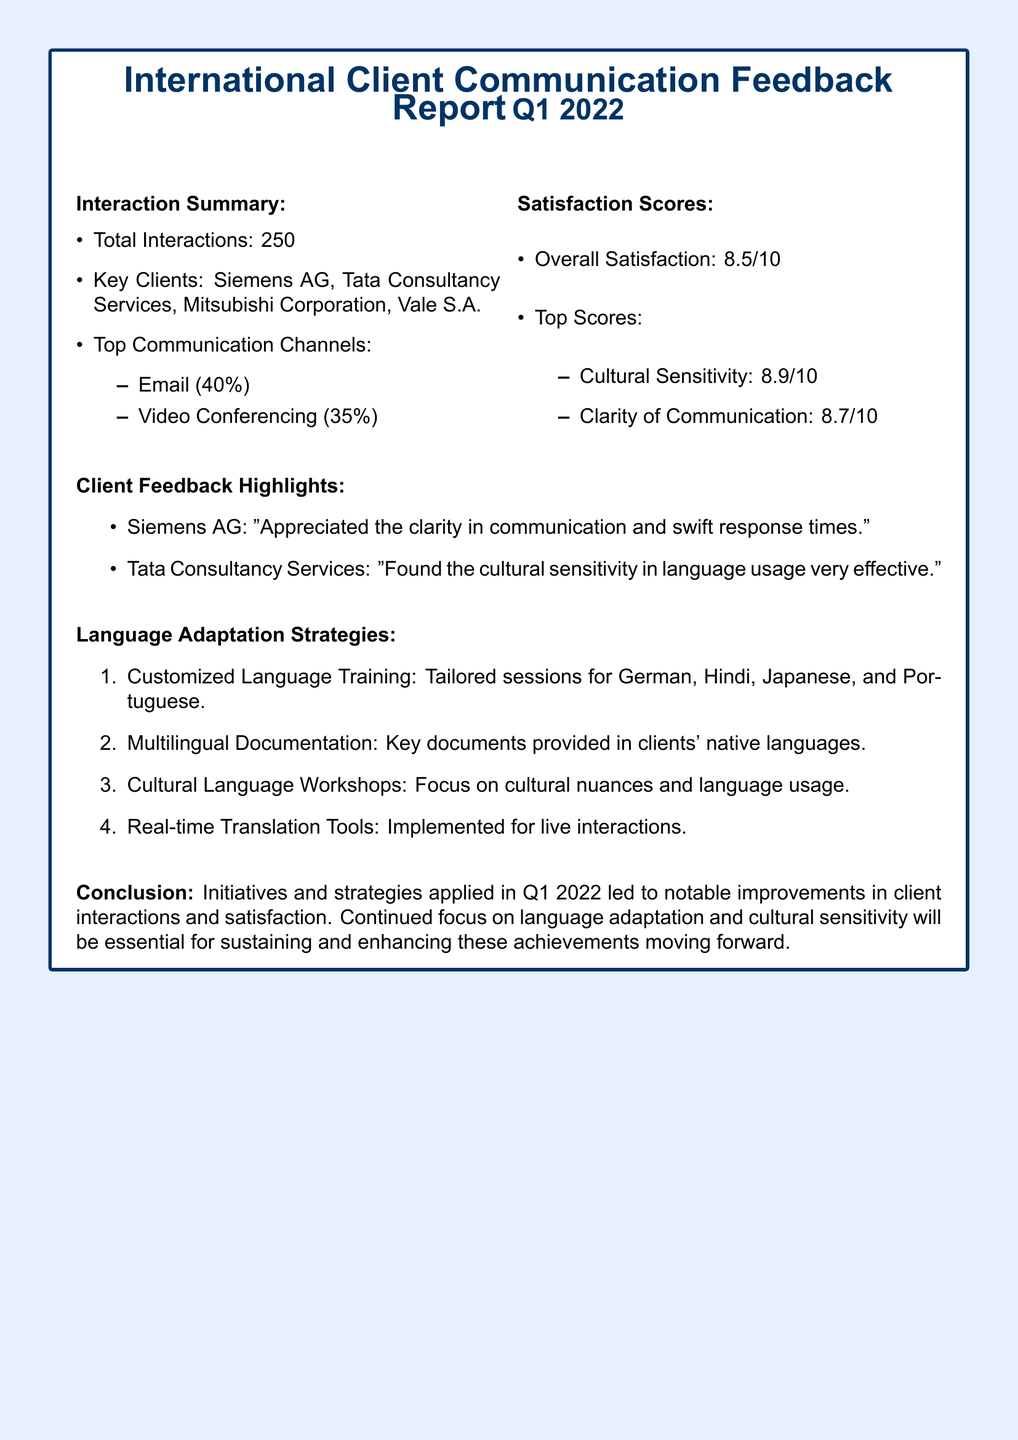what was the overall satisfaction score? The overall satisfaction score is explicitly mentioned in the document.
Answer: 8.5/10 how many total interactions were reported? The document specifies the total number of interactions recorded during the quarter.
Answer: 250 which client appreciated clarity in communication? The feedback from Siemens AG highlights their appreciation for clarity in communication.
Answer: Siemens AG what percentage of communication was conducted via email? The document lists the percentage of interactions conducted through email.
Answer: 40% what are the top scores in the satisfaction section? The document lists the top satisfaction scores, specifically under cultural sensitivity and clarity of communication.
Answer: Cultural Sensitivity: 8.9/10, Clarity of Communication: 8.7/10 which communication channel had the highest percentage? The document indicates which communication channel was the most used during interactions.
Answer: Email what language adaptation strategy involves tailored sessions? The document details various strategies focusing on language and cultural training.
Answer: Customized Language Training how many key clients are mentioned in the report? The report provides a list of key clients relevant to the interactions.
Answer: 4 what feedback did Tata Consultancy Services provide regarding language usage? The document summarizes the specific feedback from Tata Consultancy Services about communication strategies.
Answer: Cultural sensitivity in language usage very effective 